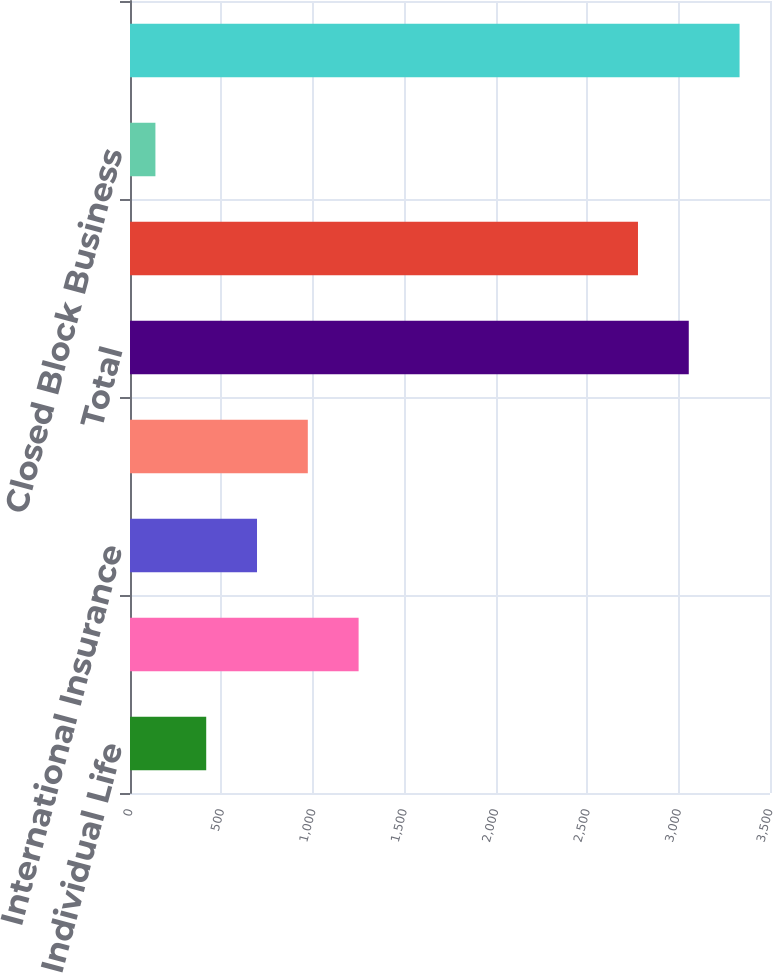Convert chart to OTSL. <chart><loc_0><loc_0><loc_500><loc_500><bar_chart><fcel>Individual Life<fcel>Total Insurance Division<fcel>International Insurance<fcel>Total International Insurance<fcel>Total<fcel>Total Financial Services<fcel>Closed Block Business<fcel>Total per Consolidated<nl><fcel>416.8<fcel>1250.2<fcel>694.6<fcel>972.4<fcel>3055.8<fcel>2778<fcel>139<fcel>3333.6<nl></chart> 